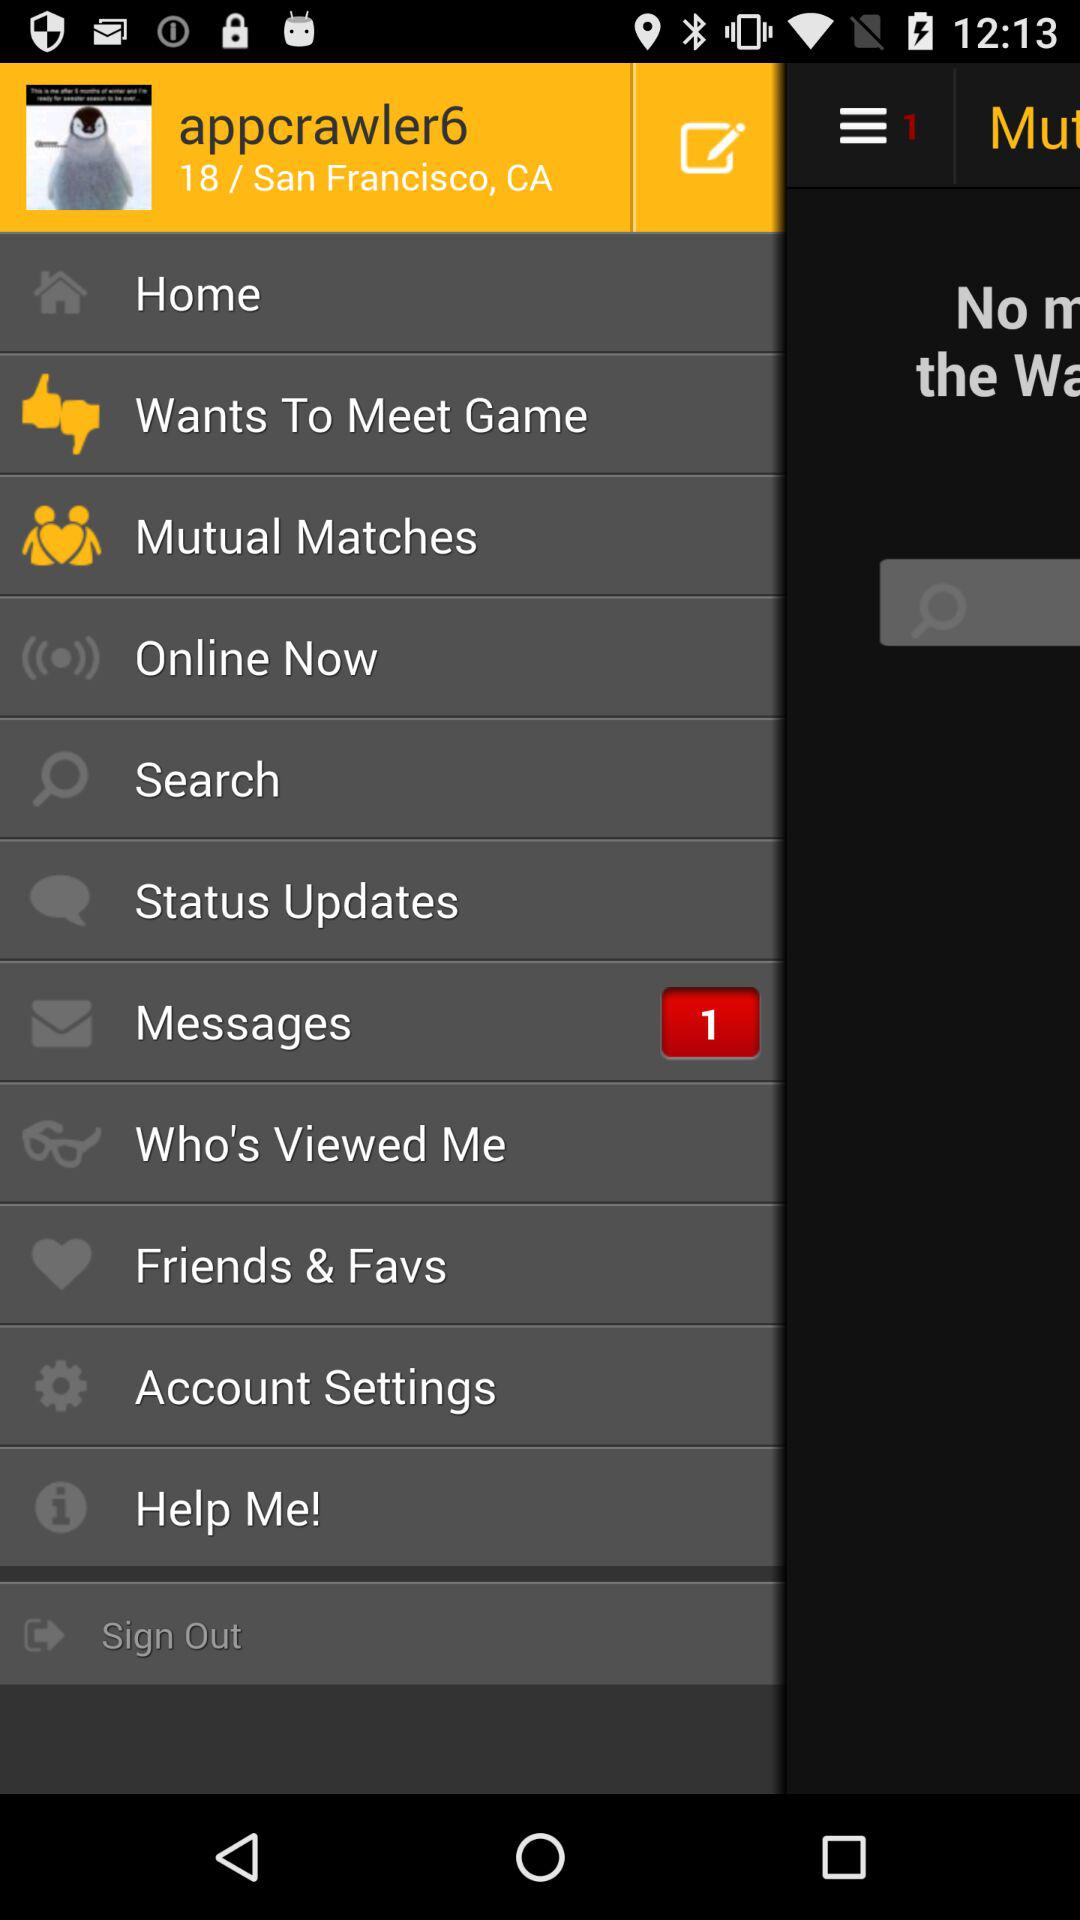What is the username? The username is "appcrawler6". 